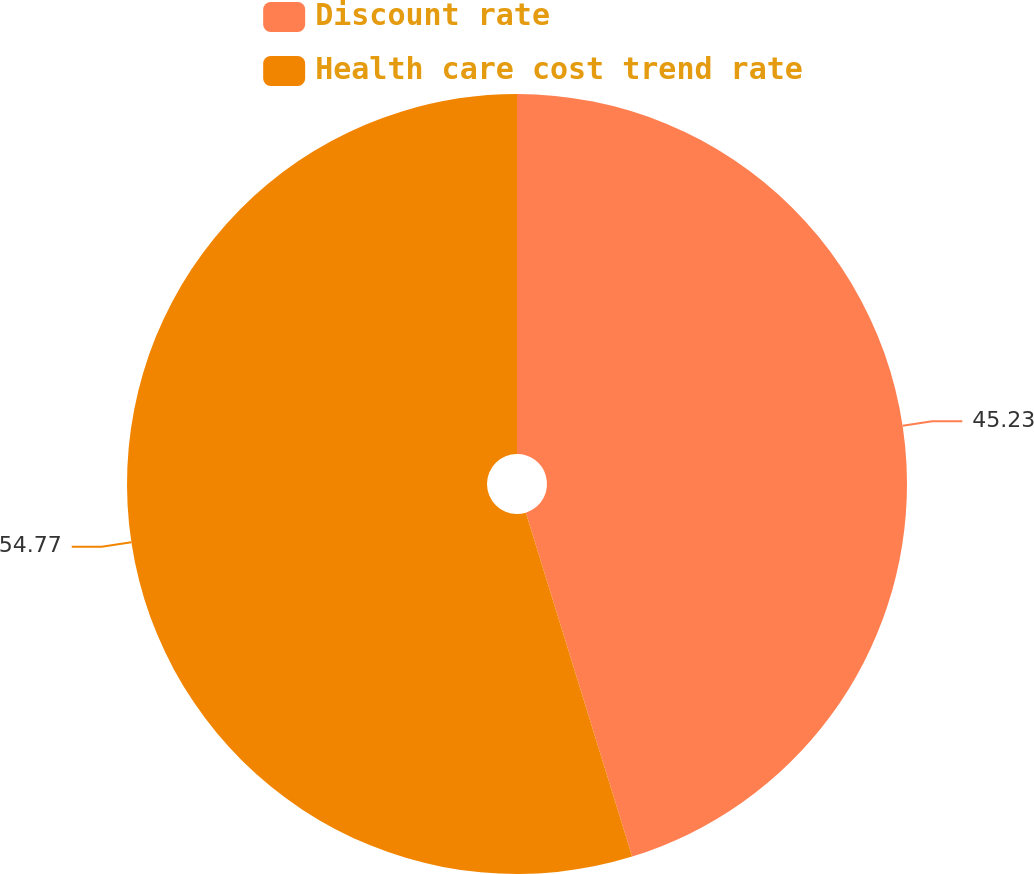Convert chart to OTSL. <chart><loc_0><loc_0><loc_500><loc_500><pie_chart><fcel>Discount rate<fcel>Health care cost trend rate<nl><fcel>45.23%<fcel>54.77%<nl></chart> 